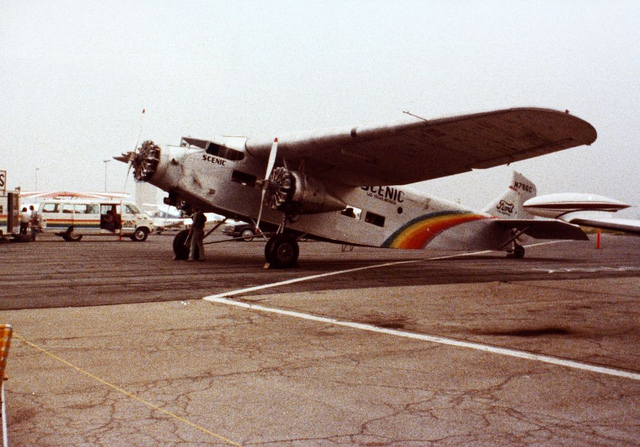What kind of aircraft is shown in this image, and what era is it from? The aircraft is a Ford Trimotor, often nicknamed 'The Tin Goose.' It is a notable aircraft from the early 20th century, specifically famous during the 1920s and 1930s for pioneering early passenger flights. 